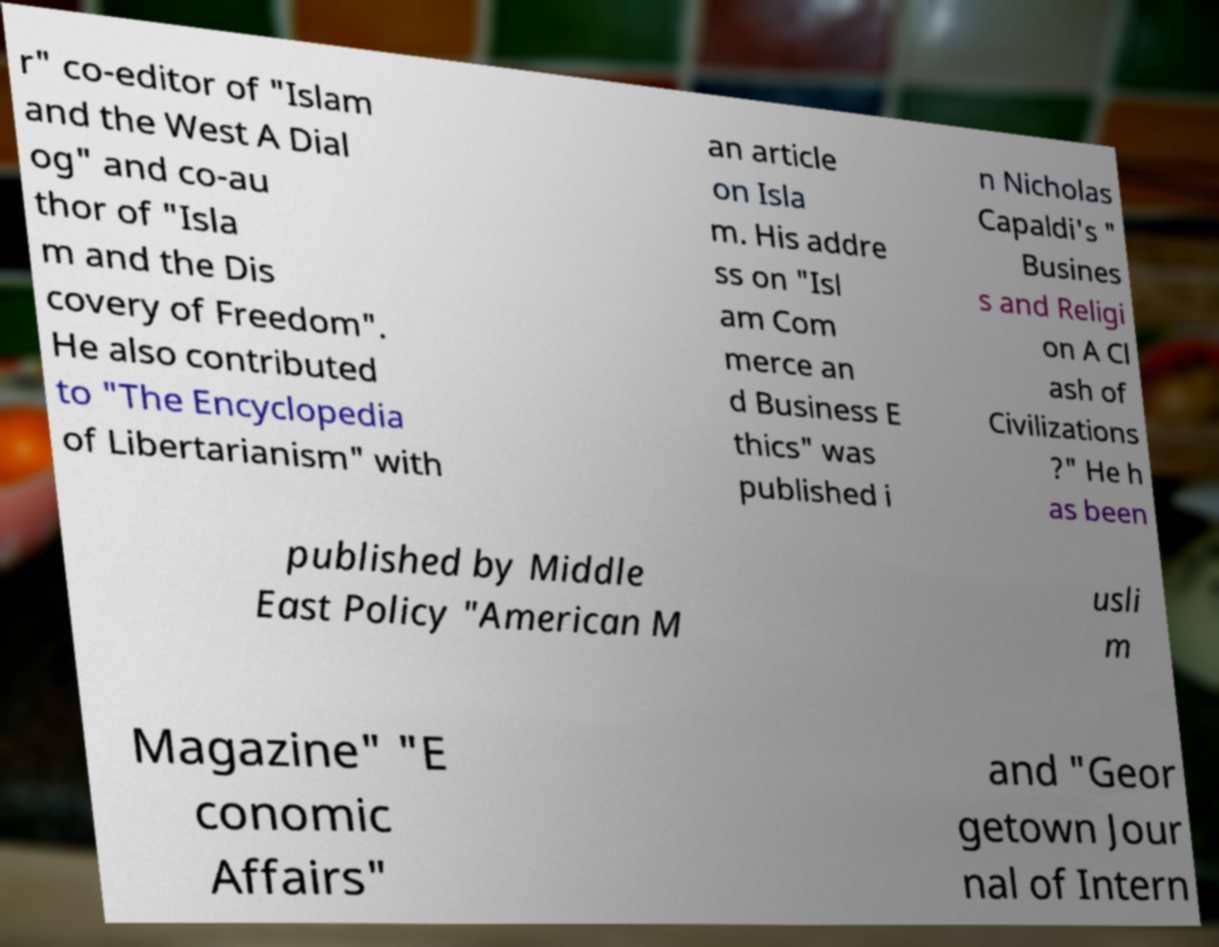What messages or text are displayed in this image? I need them in a readable, typed format. r" co-editor of "Islam and the West A Dial og" and co-au thor of "Isla m and the Dis covery of Freedom". He also contributed to "The Encyclopedia of Libertarianism" with an article on Isla m. His addre ss on "Isl am Com merce an d Business E thics" was published i n Nicholas Capaldi's " Busines s and Religi on A Cl ash of Civilizations ?" He h as been published by Middle East Policy "American M usli m Magazine" "E conomic Affairs" and "Geor getown Jour nal of Intern 